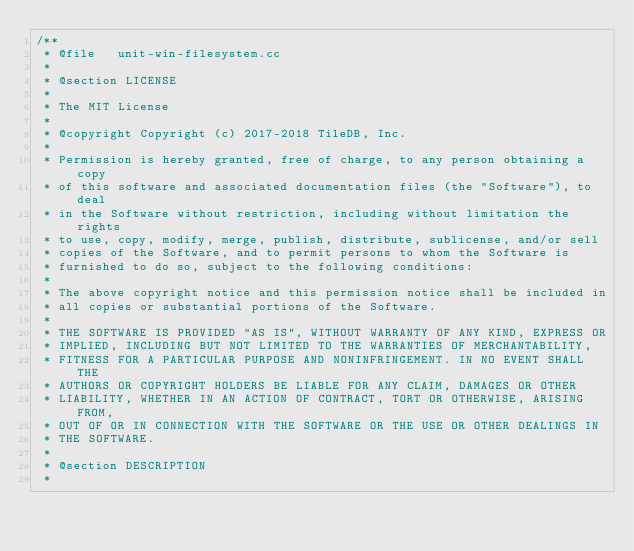<code> <loc_0><loc_0><loc_500><loc_500><_C++_>/**
 * @file   unit-win-filesystem.cc
 *
 * @section LICENSE
 *
 * The MIT License
 *
 * @copyright Copyright (c) 2017-2018 TileDB, Inc.
 *
 * Permission is hereby granted, free of charge, to any person obtaining a copy
 * of this software and associated documentation files (the "Software"), to deal
 * in the Software without restriction, including without limitation the rights
 * to use, copy, modify, merge, publish, distribute, sublicense, and/or sell
 * copies of the Software, and to permit persons to whom the Software is
 * furnished to do so, subject to the following conditions:
 *
 * The above copyright notice and this permission notice shall be included in
 * all copies or substantial portions of the Software.
 *
 * THE SOFTWARE IS PROVIDED "AS IS", WITHOUT WARRANTY OF ANY KIND, EXPRESS OR
 * IMPLIED, INCLUDING BUT NOT LIMITED TO THE WARRANTIES OF MERCHANTABILITY,
 * FITNESS FOR A PARTICULAR PURPOSE AND NONINFRINGEMENT. IN NO EVENT SHALL THE
 * AUTHORS OR COPYRIGHT HOLDERS BE LIABLE FOR ANY CLAIM, DAMAGES OR OTHER
 * LIABILITY, WHETHER IN AN ACTION OF CONTRACT, TORT OR OTHERWISE, ARISING FROM,
 * OUT OF OR IN CONNECTION WITH THE SOFTWARE OR THE USE OR OTHER DEALINGS IN
 * THE SOFTWARE.
 *
 * @section DESCRIPTION
 *</code> 